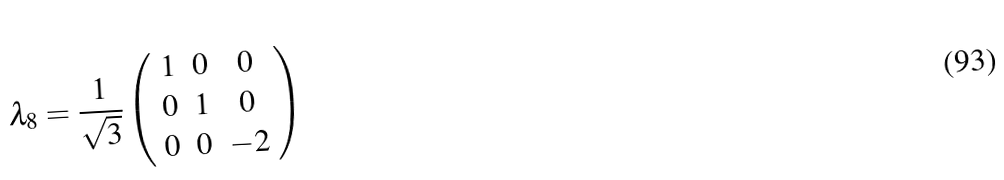Convert formula to latex. <formula><loc_0><loc_0><loc_500><loc_500>\lambda _ { 8 } = \frac { 1 } { \sqrt { 3 } } \left ( \begin{array} [ c ] { c c c } 1 & 0 & 0 \\ 0 & 1 & 0 \\ 0 & 0 & - 2 \end{array} \right )</formula> 